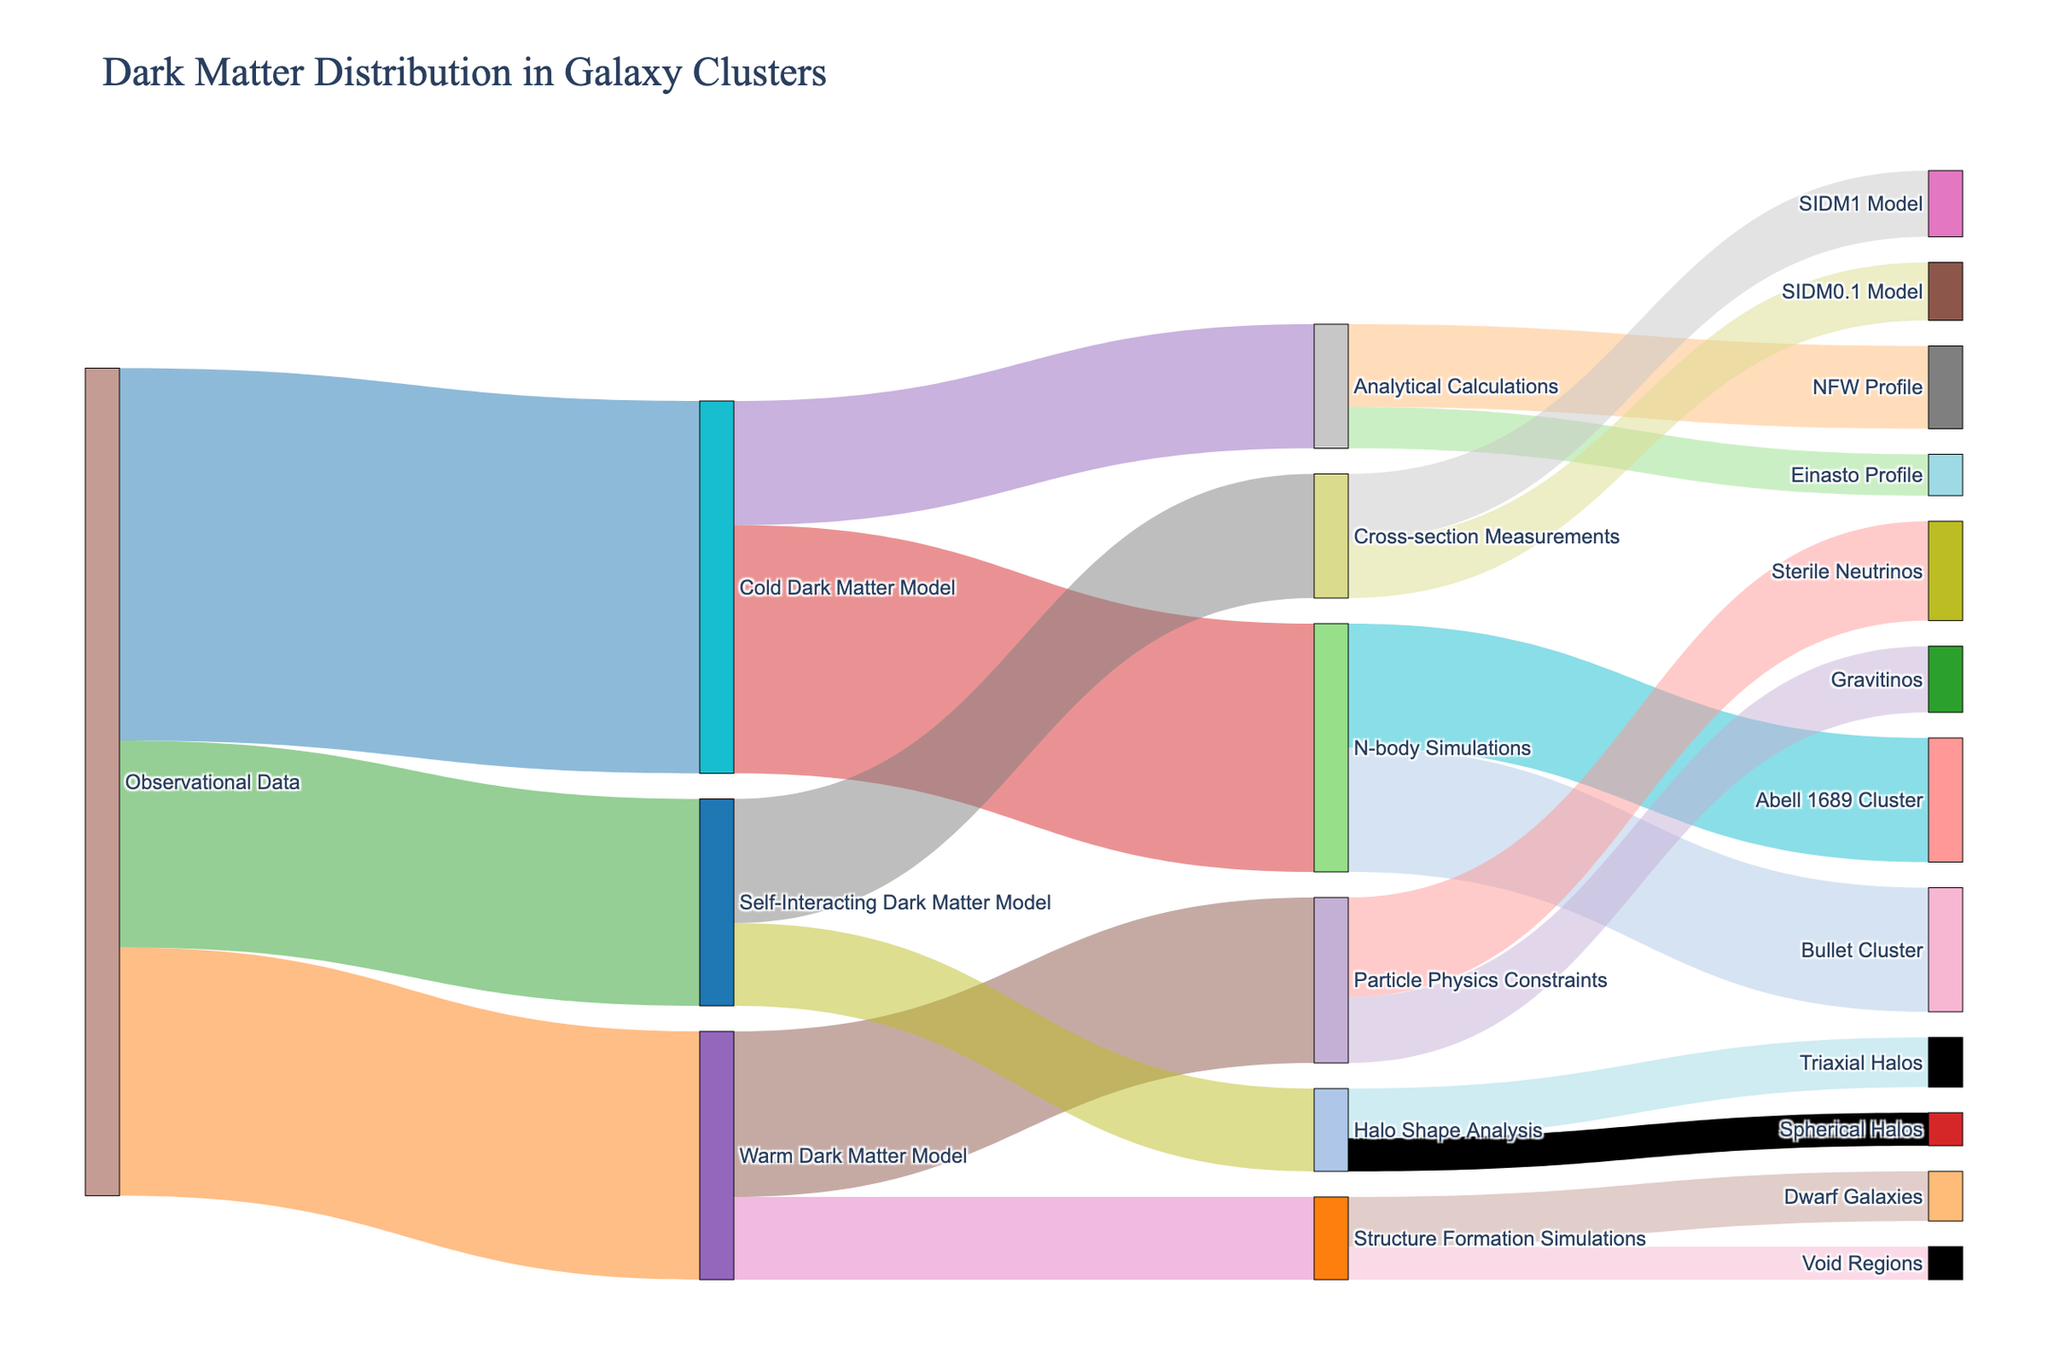What is the title of the figure? The title is displayed prominently at the top of the figure. It provides a general overview of the subject matter of the Sankey Diagram.
Answer: Dark Matter Distribution in Galaxy Clusters How many models are derived directly from the observational data? Look at the links starting from "Observational Data"; count the number of targets they connect to.
Answer: 3 What is the total value of dark matter accounted for by the Cold Dark Matter Model? Add the values from all targets connected to the "Cold Dark Matter Model". So, it is (30 + 15).
Answer: 45 Which theoretical model contributes less to the particle physics constraints: Gravitinos or Sterile Neutrinos? By how much? Compare the values for "Gravitinos" and "Sterile Neutrinos" under the "Particle Physics Constraints". The difference is the value of "Sterile Neutrinos" minus "Gravitinos".
Answer: Sterile Neutrinos by 4 What are the final destinations (lowest level in the hierarchy) for the contributions from the Self-Interacting Dark Matter Model? Trace the paths from the "Self-Interacting Dark Matter Model" to their final targets, looking at both "Cross-section Measurements" and "Halo Shape Analysis". The final destinations are "SIDM1 Model", "SIDM0.1 Model", "Triaxial Halos", and "Spherical Halos".
Answer: SIDM1 Model, SIDM0.1 Model, Triaxial Halos, Spherical Halos Which cluster has the same total value of dark matter from N-body Simulations? Look at the values for the targets "Abell 1689 Cluster" and "Bullet Cluster" connected to "N-body Simulations". Compare these values; both clusters have the same value.
Answer: Abell 1689 Cluster and Bullet Cluster If you add the values of analytical calculations, warm dark matter model, and self-interacting dark matter model that contribute to the halo shape analysis, what is the total value? Identify the paths leading to "Halo Shape Analysis" from "Analytical Calculations", "Warm Dark Matter Model", and "Self-Interacting Dark Matter Model". Sum the values of these contributions. However, only "Self-Interacting Dark Matter Model" contributes to "Halo Shape Analysis": (6 + 4).
Answer: 10 What is the total value of contributions to dwarf galaxies and void regions combined from the warm dark matter model? Sum the values from the "Structure Formation Simulations" (targets "Dwarf Galaxies" and "Void Regions").
Answer: 10 Which specific dark matter model has the highest direct contribution according to the Sankey Diagram? Compare the values of the models directly connected to "Observational Data", namely the models: "Cold Dark Matter Model", "Warm Dark Matter Model", and "Self-Interacting Dark Matter Model". The highest value corresponds to the highest number.
Answer: Cold Dark Matter Model How much more value does the Abell 1689 Cluster have compared to the Void Regions? Identify the values for "Abell 1689 Cluster" and "Void Regions". Subtract the value of "Void Regions" from "Abell 1689 Cluster".
Answer: 11 